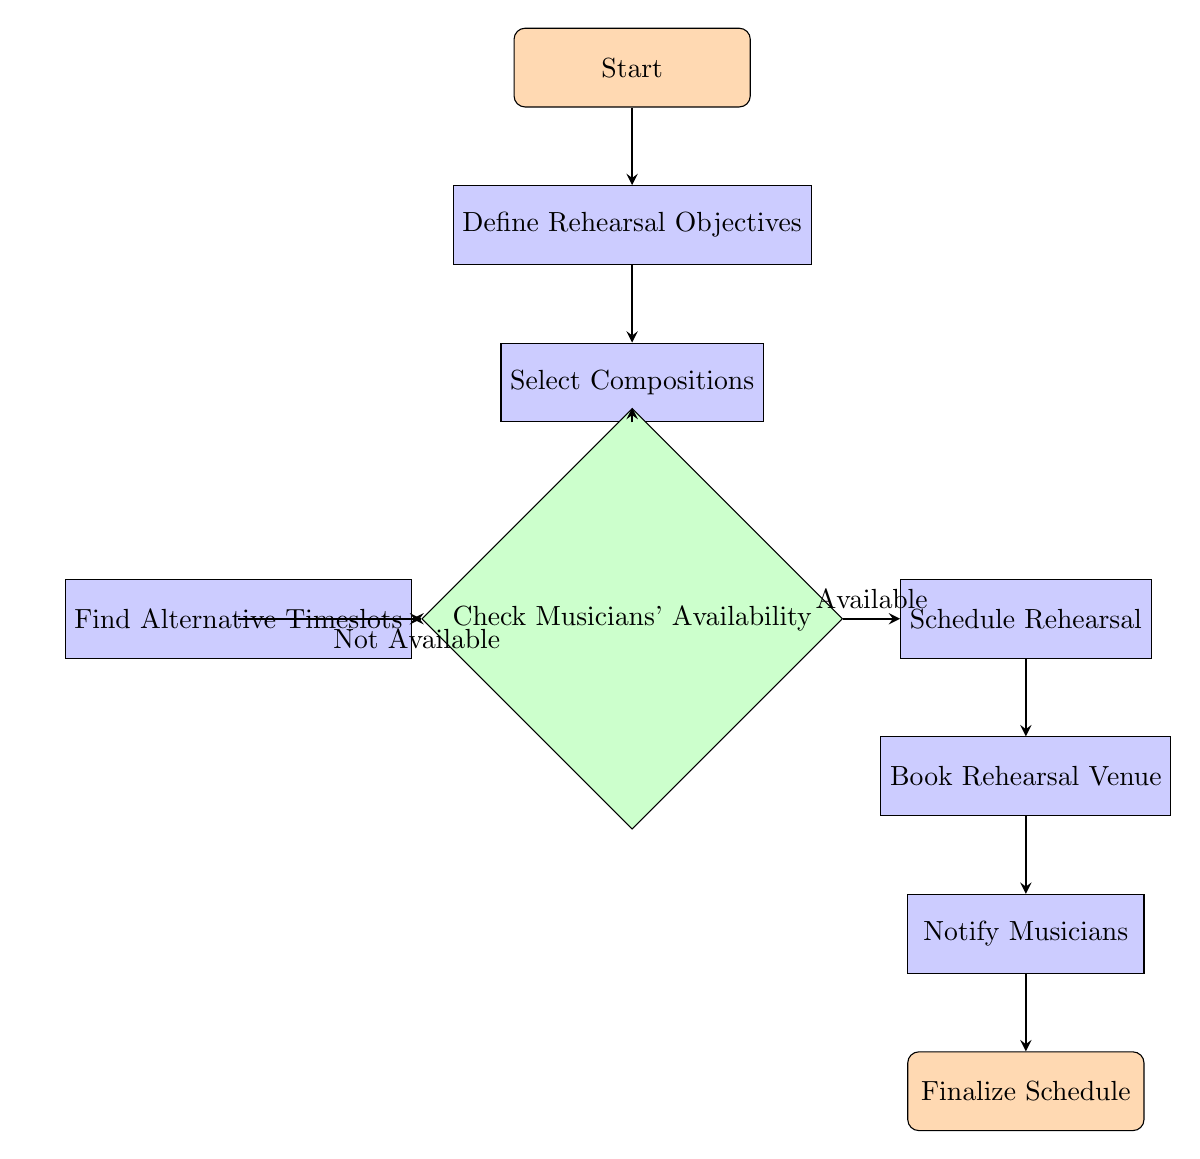What's the first step in the diagram? The first step in the diagram is represented as the "Start" node, which initiates the process.
Answer: Start How many decision nodes are in the diagram? The diagram contains one decision node, which is the "Check Musicians' Availability" node.
Answer: 1 What follows the "Select Compositions" process? After the "Select Compositions" process, the next step is the "Check Musicians' Availability" decision node.
Answer: Check Musicians' Availability What option leads to "Schedule Rehearsal"? The option that leads to "Schedule Rehearsal" is labeled "Available," which indicates that musicians are available for rehearsal.
Answer: Available How many processes are there in total? There are five process nodes in total: "Define Rehearsal Objectives," "Select Compositions," "Schedule Rehearsal," "Book Rehearsal Venue," and "Notify Musicians."
Answer: 5 If musicians are not available, what is the next step? If musicians are not available, the next step is to "Find Alternative Timeslots," which allows for rescheduling.
Answer: Find Alternative Timeslots What is the final step in the flow chart? The final step in the flow chart is the "Finalize Schedule" node, which concludes the scheduling process.
Answer: Finalize Schedule What is the relationship between "Notify Musicians" and "Finalize Schedule"? The relationship is sequential; "Notify Musicians" directly leads to the "Finalize Schedule," completing the overall scheduling process.
Answer: Sequential How many direct connections are there from the "Check Musicians' Availability" node? There are two direct connections from the "Check Musicians' Availability" node—one leading to "Schedule Rehearsal" and the other to "Find Alternative Timeslots."
Answer: 2 